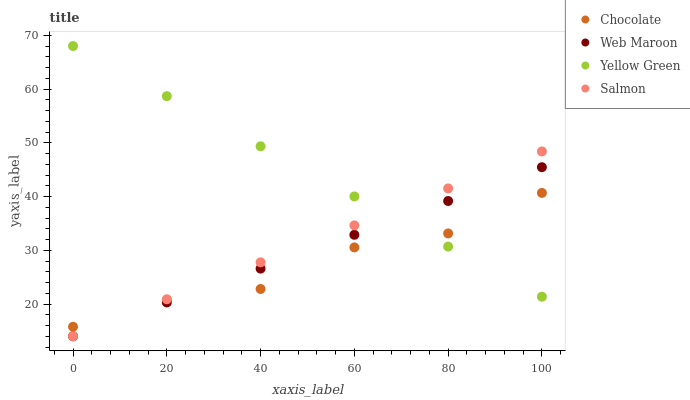Does Chocolate have the minimum area under the curve?
Answer yes or no. Yes. Does Yellow Green have the maximum area under the curve?
Answer yes or no. Yes. Does Web Maroon have the minimum area under the curve?
Answer yes or no. No. Does Web Maroon have the maximum area under the curve?
Answer yes or no. No. Is Salmon the smoothest?
Answer yes or no. Yes. Is Chocolate the roughest?
Answer yes or no. Yes. Is Web Maroon the smoothest?
Answer yes or no. No. Is Web Maroon the roughest?
Answer yes or no. No. Does Salmon have the lowest value?
Answer yes or no. Yes. Does Yellow Green have the lowest value?
Answer yes or no. No. Does Yellow Green have the highest value?
Answer yes or no. Yes. Does Web Maroon have the highest value?
Answer yes or no. No. Does Salmon intersect Web Maroon?
Answer yes or no. Yes. Is Salmon less than Web Maroon?
Answer yes or no. No. Is Salmon greater than Web Maroon?
Answer yes or no. No. 